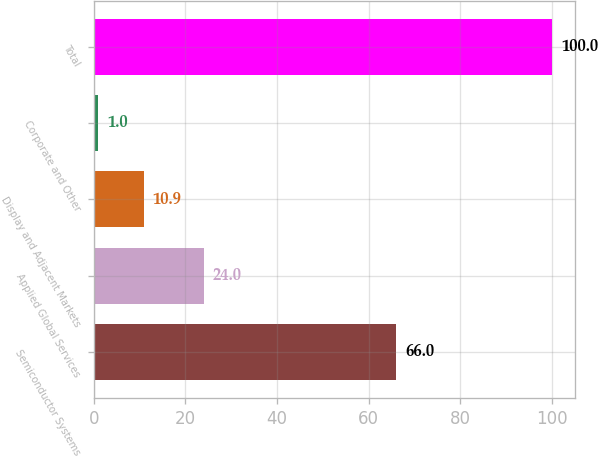Convert chart. <chart><loc_0><loc_0><loc_500><loc_500><bar_chart><fcel>Semiconductor Systems<fcel>Applied Global Services<fcel>Display and Adjacent Markets<fcel>Corporate and Other<fcel>Total<nl><fcel>66<fcel>24<fcel>10.9<fcel>1<fcel>100<nl></chart> 